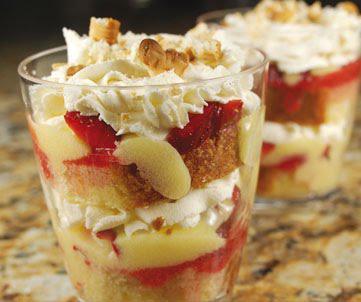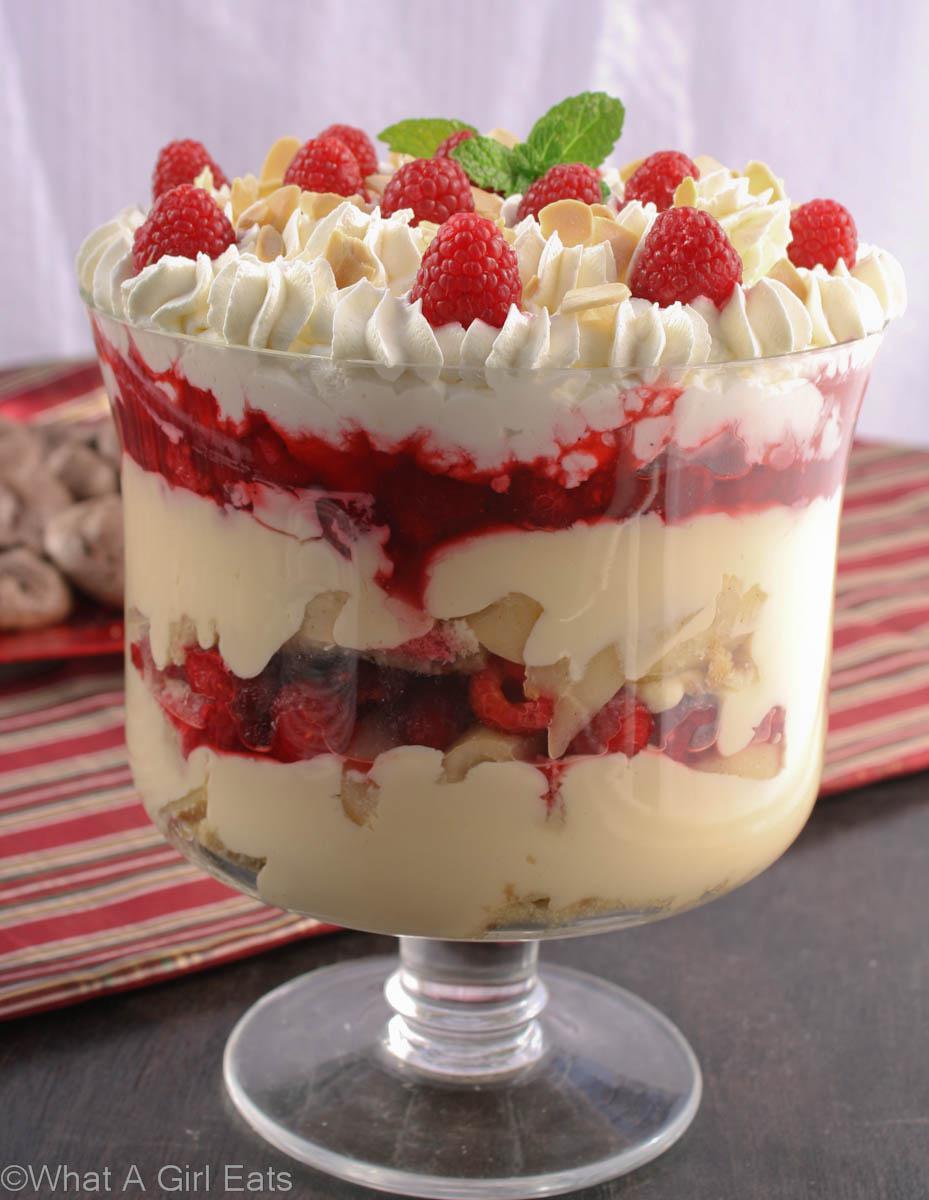The first image is the image on the left, the second image is the image on the right. For the images displayed, is the sentence "One of the images contains exactly two dessert filled containers." factually correct? Answer yes or no. Yes. 